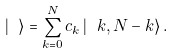<formula> <loc_0><loc_0><loc_500><loc_500>\left | \ \right \rangle = \sum _ { k = 0 } ^ { N } c _ { k } \left | \ k , N - k \right \rangle .</formula> 